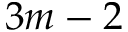<formula> <loc_0><loc_0><loc_500><loc_500>3 m - 2</formula> 